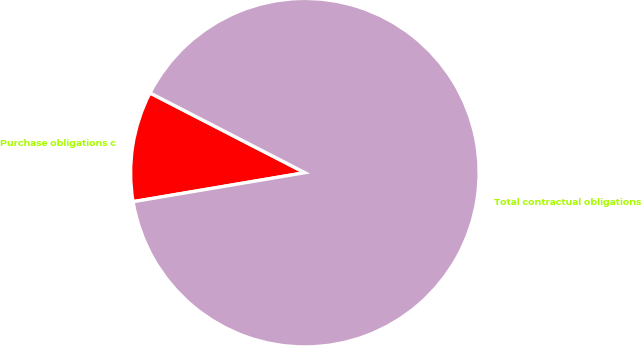<chart> <loc_0><loc_0><loc_500><loc_500><pie_chart><fcel>Purchase obligations c<fcel>Total contractual obligations<nl><fcel>10.23%<fcel>89.77%<nl></chart> 